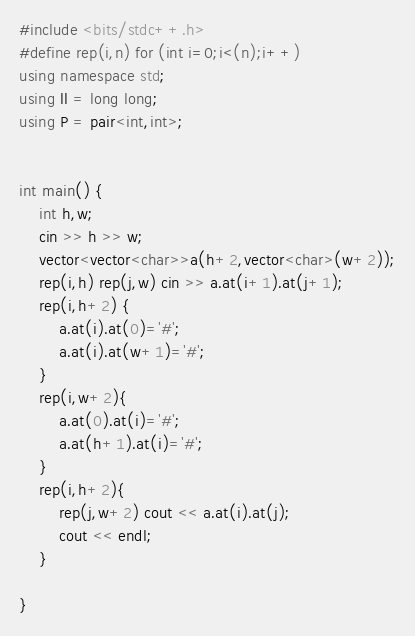Convert code to text. <code><loc_0><loc_0><loc_500><loc_500><_C++_>#include <bits/stdc++.h>
#define rep(i,n) for (int i=0;i<(n);i++)
using namespace std;
using ll = long long;
using P = pair<int,int>;
 
 
int main() {
    int h,w;
    cin >> h >> w;
    vector<vector<char>>a(h+2,vector<char>(w+2));
    rep(i,h) rep(j,w) cin >> a.at(i+1).at(j+1);
    rep(i,h+2) {
        a.at(i).at(0)='#';
        a.at(i).at(w+1)='#';
    }
    rep(i,w+2){
        a.at(0).at(i)='#';
        a.at(h+1).at(i)='#';
    }
    rep(i,h+2){
        rep(j,w+2) cout << a.at(i).at(j);
        cout << endl;
    }

}</code> 